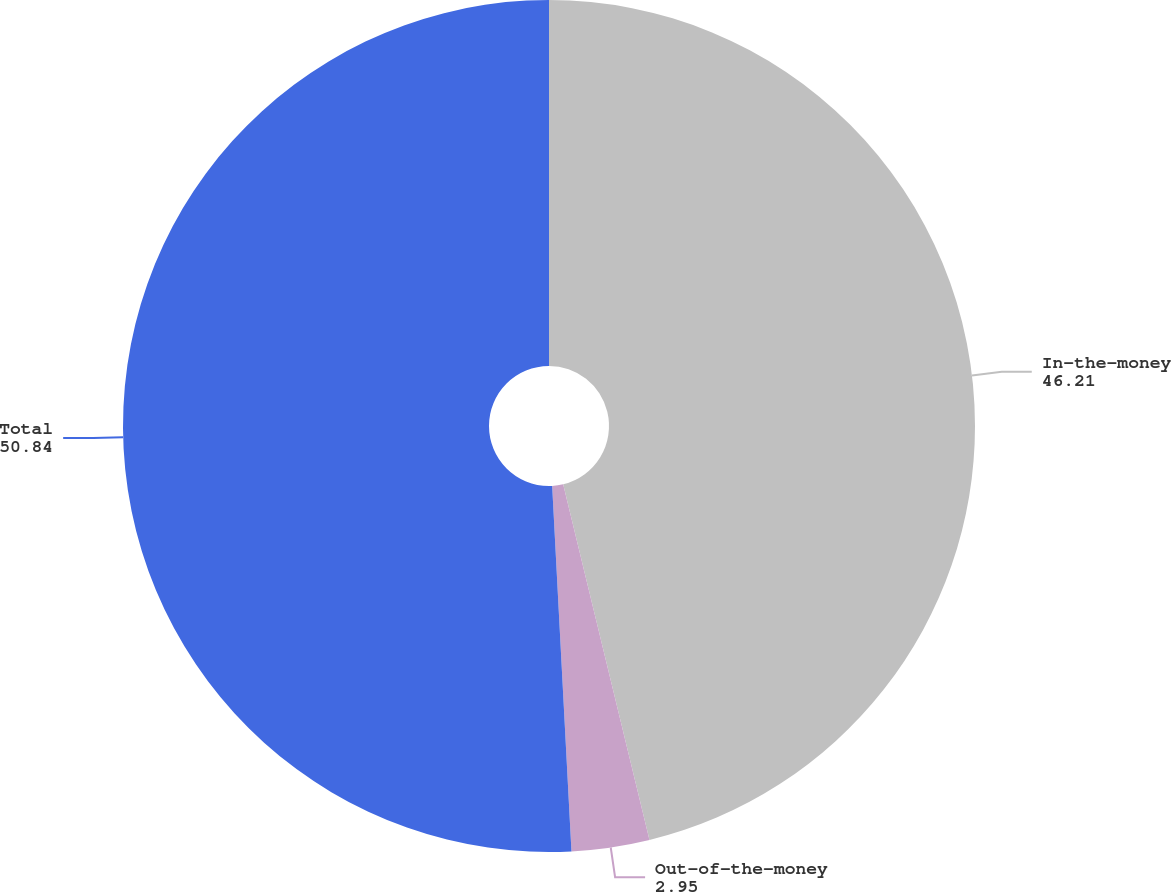<chart> <loc_0><loc_0><loc_500><loc_500><pie_chart><fcel>In-the-money<fcel>Out-of-the-money<fcel>Total<nl><fcel>46.21%<fcel>2.95%<fcel>50.84%<nl></chart> 